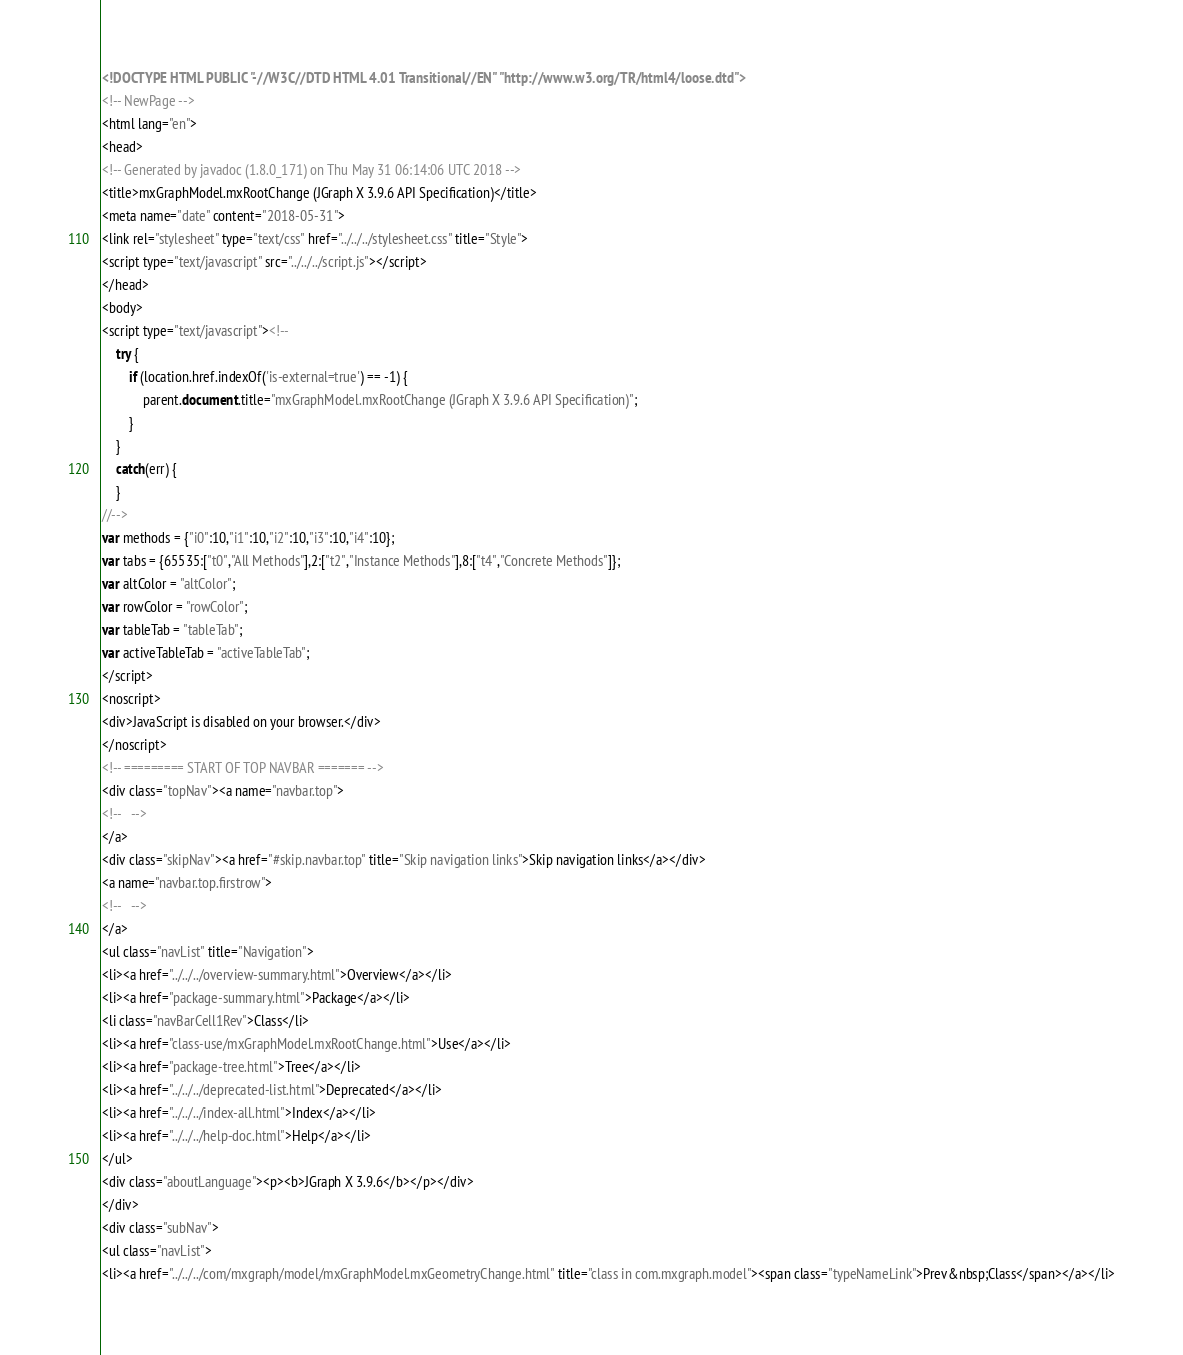<code> <loc_0><loc_0><loc_500><loc_500><_HTML_><!DOCTYPE HTML PUBLIC "-//W3C//DTD HTML 4.01 Transitional//EN" "http://www.w3.org/TR/html4/loose.dtd">
<!-- NewPage -->
<html lang="en">
<head>
<!-- Generated by javadoc (1.8.0_171) on Thu May 31 06:14:06 UTC 2018 -->
<title>mxGraphModel.mxRootChange (JGraph X 3.9.6 API Specification)</title>
<meta name="date" content="2018-05-31">
<link rel="stylesheet" type="text/css" href="../../../stylesheet.css" title="Style">
<script type="text/javascript" src="../../../script.js"></script>
</head>
<body>
<script type="text/javascript"><!--
    try {
        if (location.href.indexOf('is-external=true') == -1) {
            parent.document.title="mxGraphModel.mxRootChange (JGraph X 3.9.6 API Specification)";
        }
    }
    catch(err) {
    }
//-->
var methods = {"i0":10,"i1":10,"i2":10,"i3":10,"i4":10};
var tabs = {65535:["t0","All Methods"],2:["t2","Instance Methods"],8:["t4","Concrete Methods"]};
var altColor = "altColor";
var rowColor = "rowColor";
var tableTab = "tableTab";
var activeTableTab = "activeTableTab";
</script>
<noscript>
<div>JavaScript is disabled on your browser.</div>
</noscript>
<!-- ========= START OF TOP NAVBAR ======= -->
<div class="topNav"><a name="navbar.top">
<!--   -->
</a>
<div class="skipNav"><a href="#skip.navbar.top" title="Skip navigation links">Skip navigation links</a></div>
<a name="navbar.top.firstrow">
<!--   -->
</a>
<ul class="navList" title="Navigation">
<li><a href="../../../overview-summary.html">Overview</a></li>
<li><a href="package-summary.html">Package</a></li>
<li class="navBarCell1Rev">Class</li>
<li><a href="class-use/mxGraphModel.mxRootChange.html">Use</a></li>
<li><a href="package-tree.html">Tree</a></li>
<li><a href="../../../deprecated-list.html">Deprecated</a></li>
<li><a href="../../../index-all.html">Index</a></li>
<li><a href="../../../help-doc.html">Help</a></li>
</ul>
<div class="aboutLanguage"><p><b>JGraph X 3.9.6</b></p></div>
</div>
<div class="subNav">
<ul class="navList">
<li><a href="../../../com/mxgraph/model/mxGraphModel.mxGeometryChange.html" title="class in com.mxgraph.model"><span class="typeNameLink">Prev&nbsp;Class</span></a></li></code> 